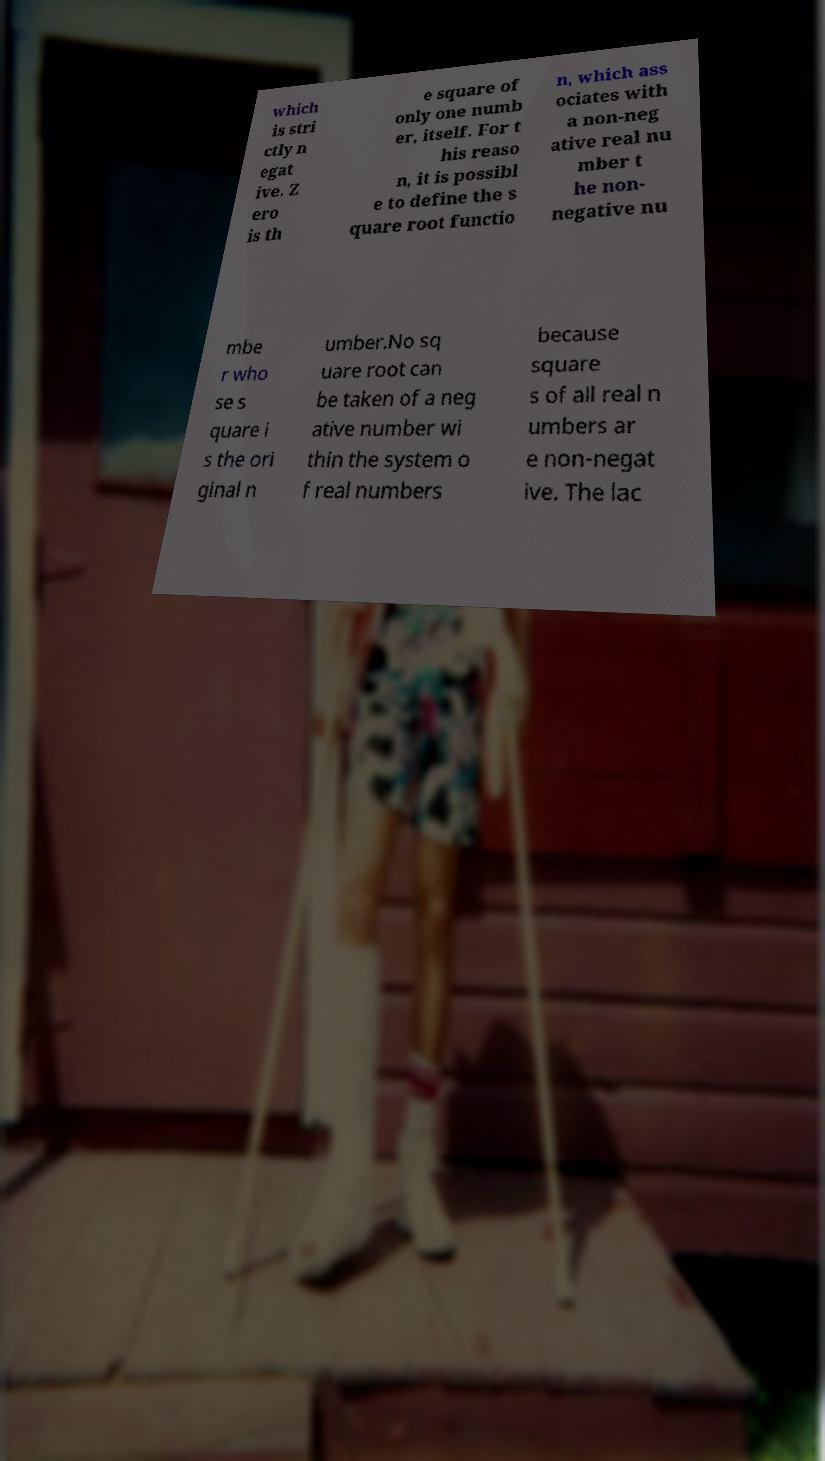Please identify and transcribe the text found in this image. which is stri ctly n egat ive. Z ero is th e square of only one numb er, itself. For t his reaso n, it is possibl e to define the s quare root functio n, which ass ociates with a non-neg ative real nu mber t he non- negative nu mbe r who se s quare i s the ori ginal n umber.No sq uare root can be taken of a neg ative number wi thin the system o f real numbers because square s of all real n umbers ar e non-negat ive. The lac 